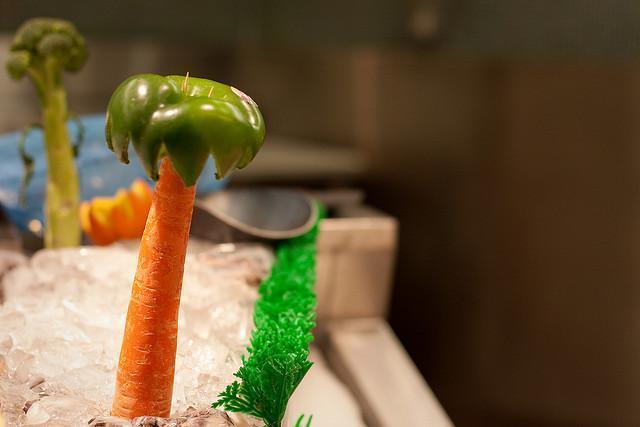How many carrots can you see?
Give a very brief answer. 1. How many of the birds are making noise?
Give a very brief answer. 0. 